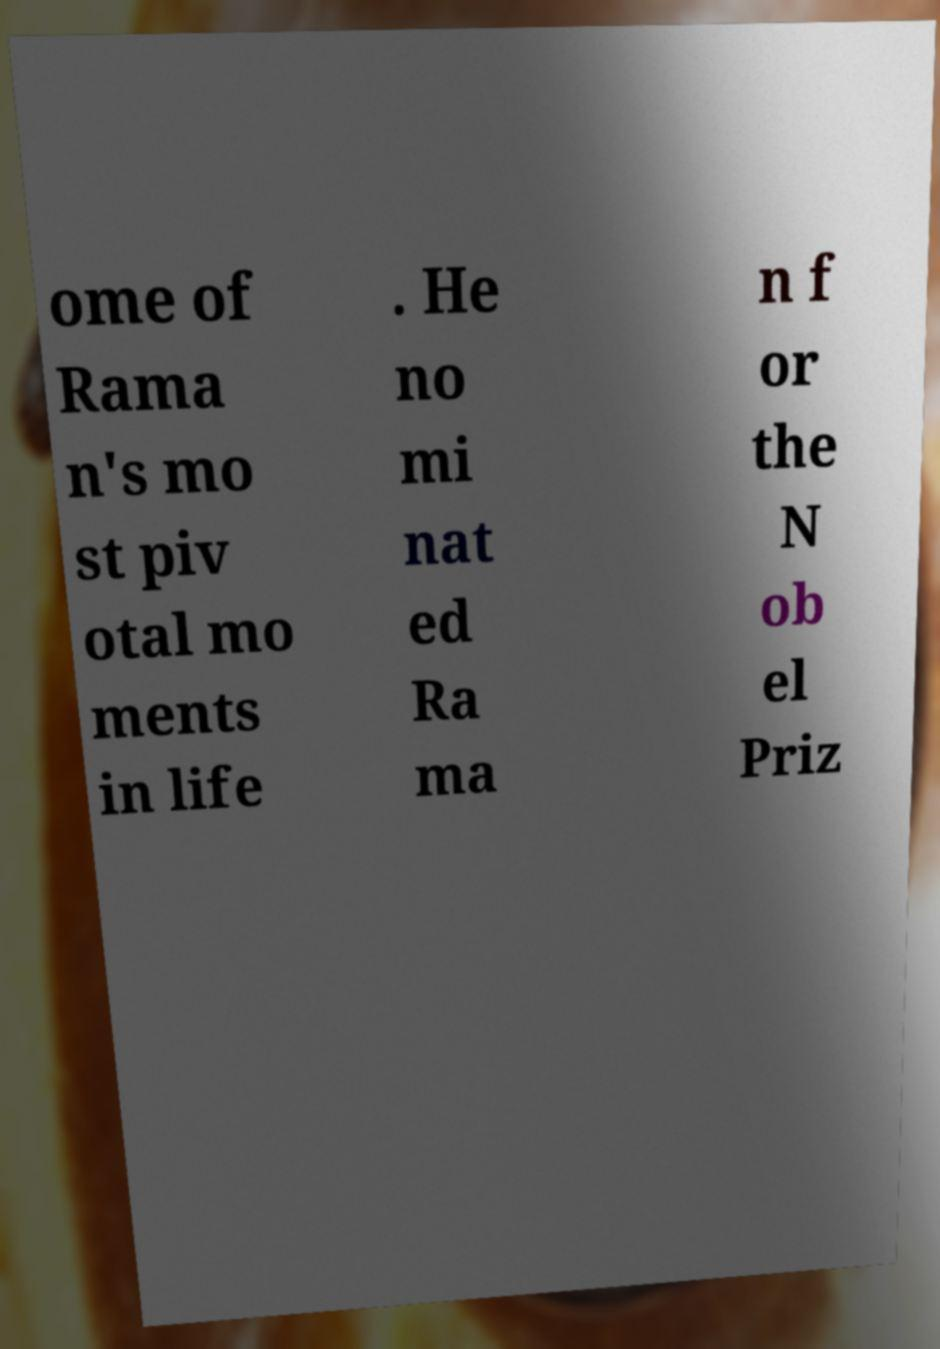Could you assist in decoding the text presented in this image and type it out clearly? ome of Rama n's mo st piv otal mo ments in life . He no mi nat ed Ra ma n f or the N ob el Priz 